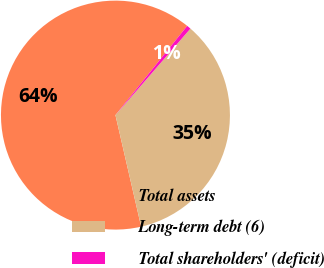Convert chart. <chart><loc_0><loc_0><loc_500><loc_500><pie_chart><fcel>Total assets<fcel>Long-term debt (6)<fcel>Total shareholders' (deficit)<nl><fcel>64.38%<fcel>35.03%<fcel>0.59%<nl></chart> 